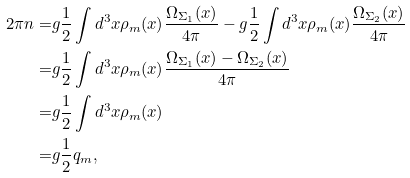<formula> <loc_0><loc_0><loc_500><loc_500>2 \pi n = & g \frac { 1 } { 2 } \int d ^ { 3 } x \rho _ { m } ( x ) \frac { \Omega _ { \Sigma _ { 1 } } ( x ) } { 4 \pi } - g \frac { 1 } { 2 } \int d ^ { 3 } x \rho _ { m } ( x ) \frac { \Omega _ { \Sigma _ { 2 } } ( x ) } { 4 \pi } \\ = & g \frac { 1 } { 2 } \int d ^ { 3 } x \rho _ { m } ( x ) \frac { \Omega _ { \Sigma _ { 1 } } ( x ) - \Omega _ { \Sigma _ { 2 } } ( x ) } { 4 \pi } \\ = & g \frac { 1 } { 2 } \int d ^ { 3 } x \rho _ { m } ( x ) \\ = & g \frac { 1 } { 2 } q _ { m } ,</formula> 